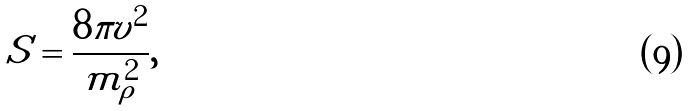Convert formula to latex. <formula><loc_0><loc_0><loc_500><loc_500>S = \frac { 8 \pi v ^ { 2 } } { m _ { \rho } ^ { 2 } } ,</formula> 